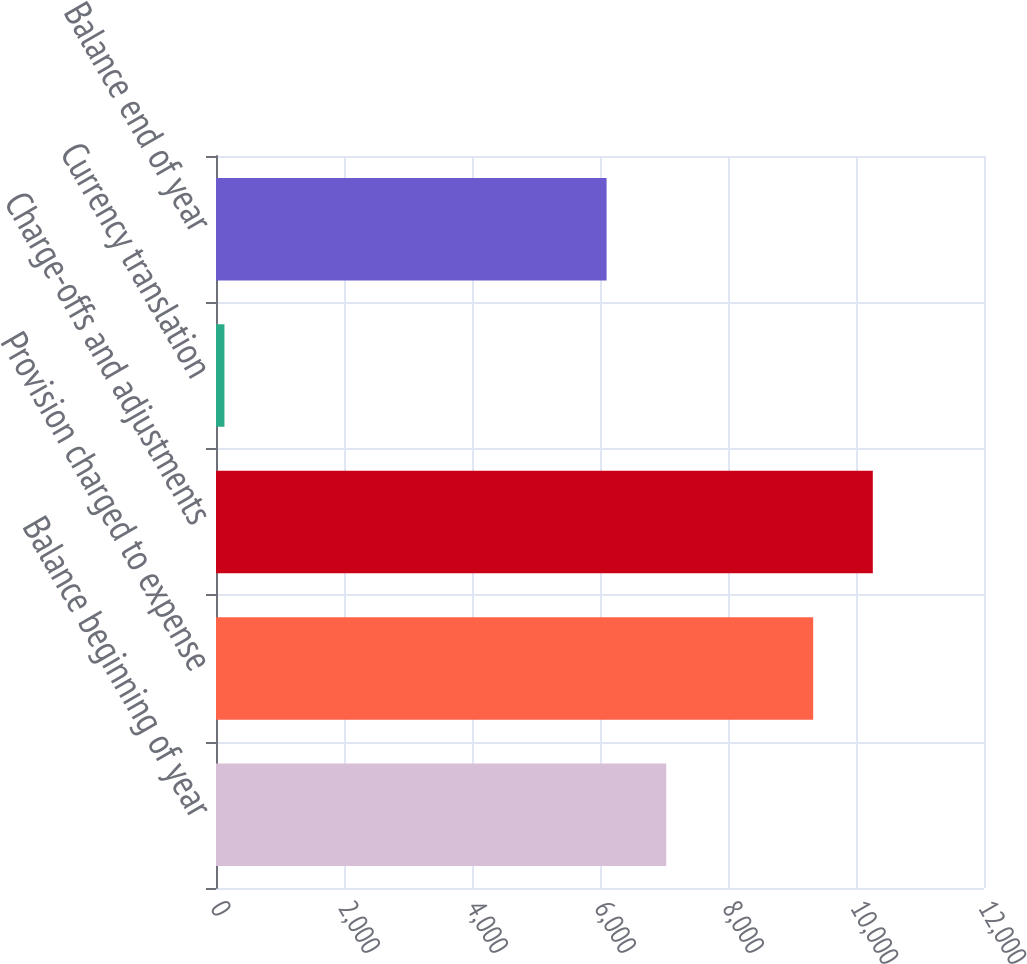Convert chart to OTSL. <chart><loc_0><loc_0><loc_500><loc_500><bar_chart><fcel>Balance beginning of year<fcel>Provision charged to expense<fcel>Charge-offs and adjustments<fcel>Currency translation<fcel>Balance end of year<nl><fcel>7034.7<fcel>9331<fcel>10262.7<fcel>132<fcel>6103<nl></chart> 